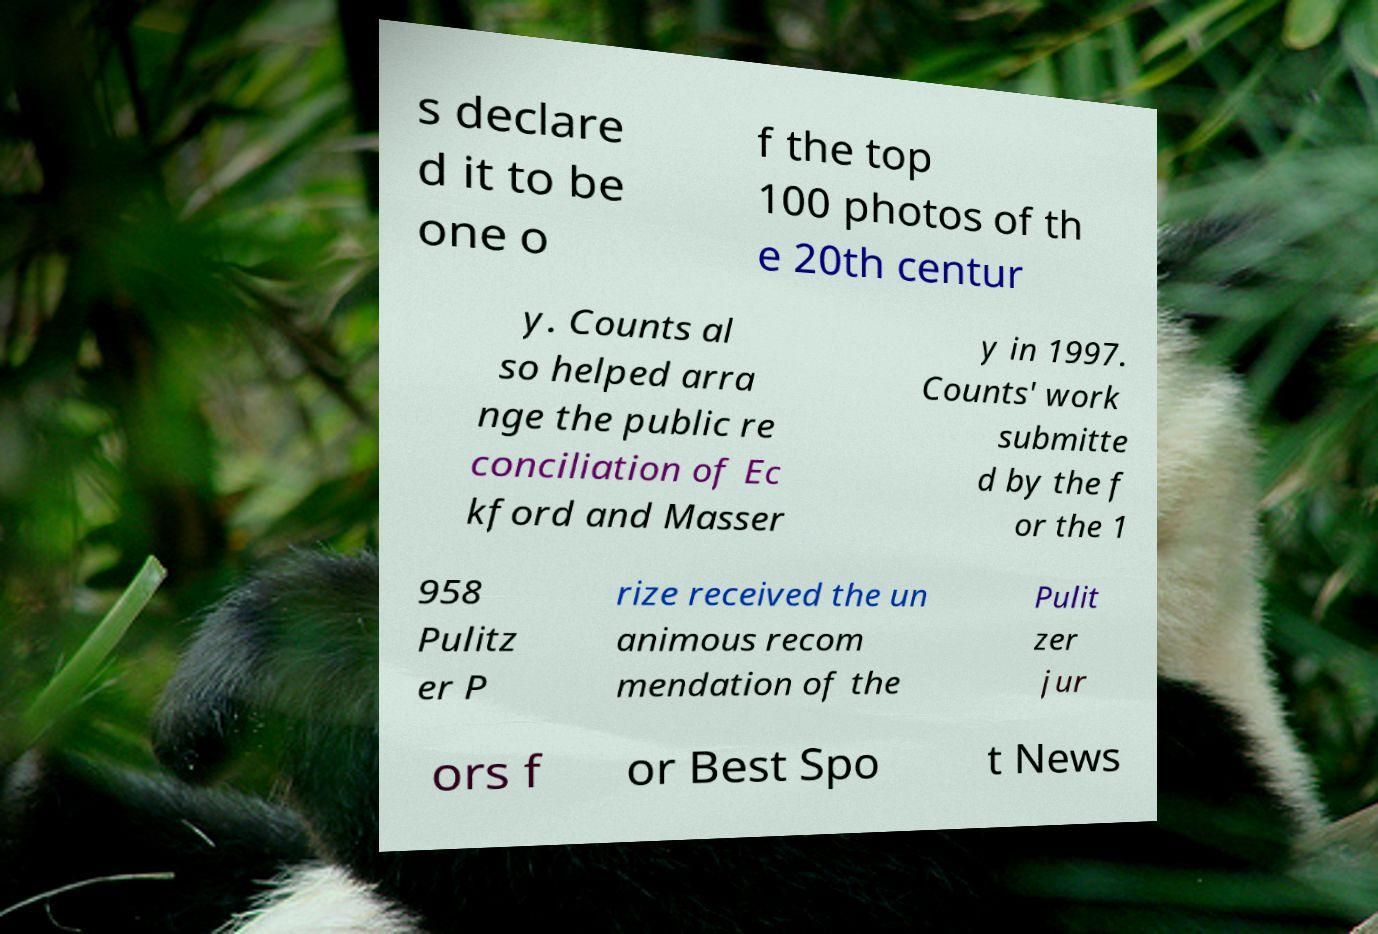For documentation purposes, I need the text within this image transcribed. Could you provide that? s declare d it to be one o f the top 100 photos of th e 20th centur y. Counts al so helped arra nge the public re conciliation of Ec kford and Masser y in 1997. Counts' work submitte d by the f or the 1 958 Pulitz er P rize received the un animous recom mendation of the Pulit zer jur ors f or Best Spo t News 